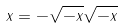Convert formula to latex. <formula><loc_0><loc_0><loc_500><loc_500>x = - \sqrt { - x } \sqrt { - x }</formula> 